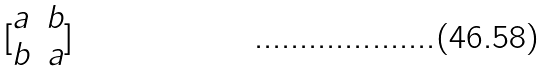Convert formula to latex. <formula><loc_0><loc_0><loc_500><loc_500>[ \begin{matrix} a & b \\ b & a \end{matrix} ]</formula> 